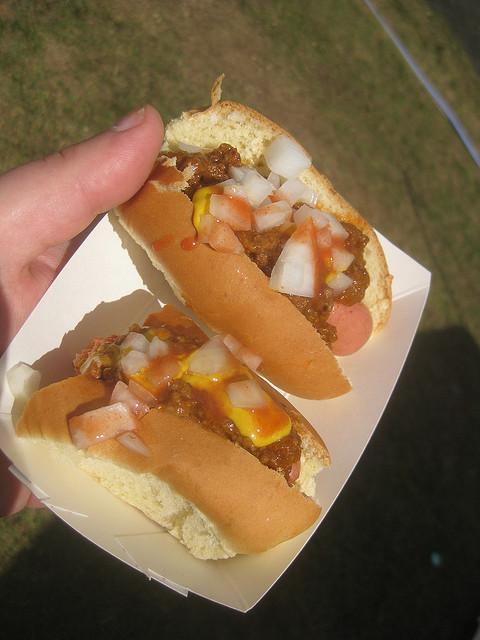Would someone eat this with their hands?
Concise answer only. Yes. How many hot dogs are there?
Answer briefly. 2. Is there any onions on the sandwiches?
Quick response, please. Yes. What kind of food is this?
Answer briefly. Hot dog. 